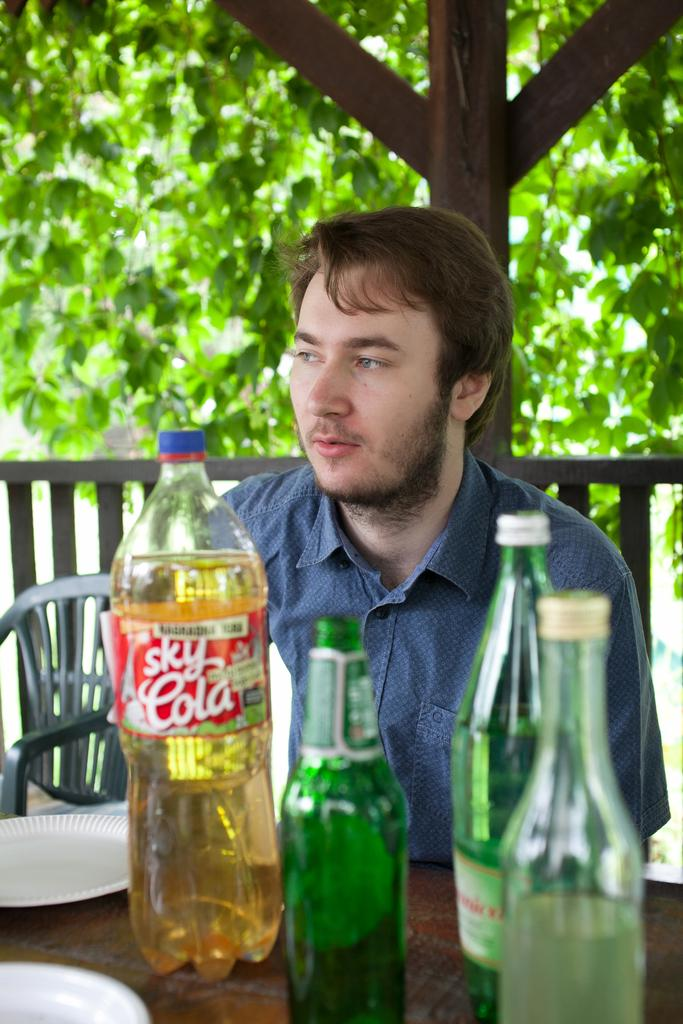<image>
Give a short and clear explanation of the subsequent image. a boy sitting behind a bottle of sky cola outside 